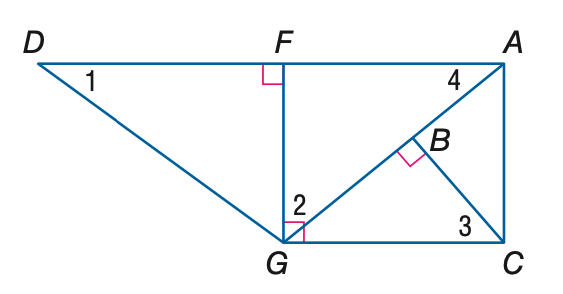Answer the mathemtical geometry problem and directly provide the correct option letter.
Question: Find the measure of \angle 4 if m \angle D G F = 53 and m \angle A G C = 40.
Choices: A: 37 B: 40 C: 50 D: 53 B 